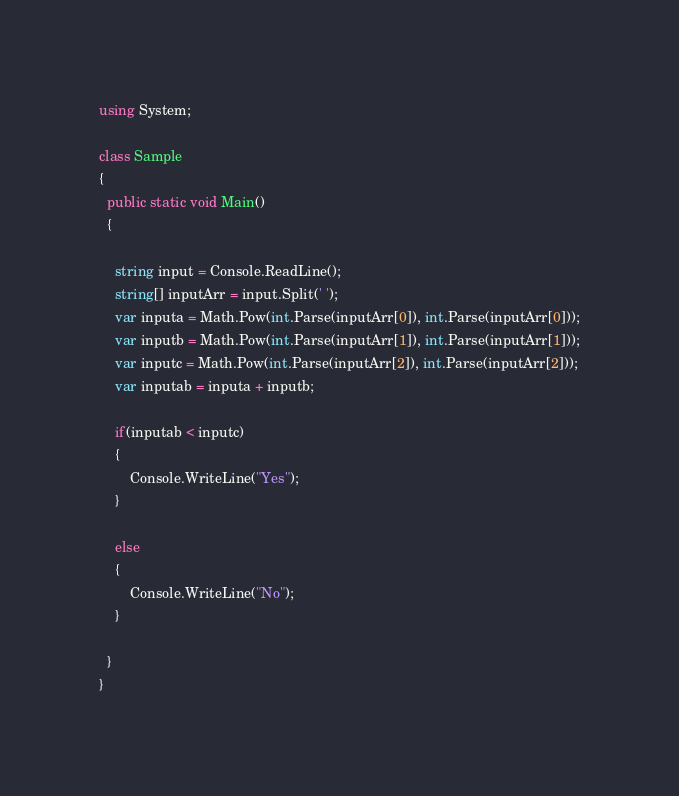Convert code to text. <code><loc_0><loc_0><loc_500><loc_500><_C#_>using System;

class Sample
{
  public static void Main()
  {
  	
    string input = Console.ReadLine();
    string[] inputArr = input.Split(' ');
    var inputa = Math.Pow(int.Parse(inputArr[0]), int.Parse(inputArr[0]));
    var inputb = Math.Pow(int.Parse(inputArr[1]), int.Parse(inputArr[1]));
    var inputc = Math.Pow(int.Parse(inputArr[2]), int.Parse(inputArr[2]));
    var inputab = inputa + inputb;
    
    if(inputab < inputc)
    {
    	Console.WriteLine("Yes");
    }
    
    else
    {
    	Console.WriteLine("No");
    }
  
  }
}

</code> 